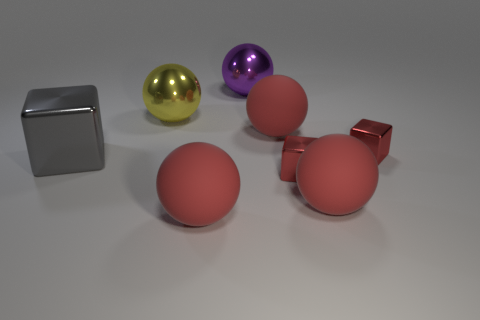Subtract all green cylinders. How many red balls are left? 3 Subtract all yellow spheres. How many spheres are left? 4 Subtract all yellow metallic balls. How many balls are left? 4 Subtract 1 blocks. How many blocks are left? 2 Subtract all spheres. How many objects are left? 3 Add 2 small red metal cubes. How many objects exist? 10 Subtract all gray balls. Subtract all yellow blocks. How many balls are left? 5 Subtract 0 brown cubes. How many objects are left? 8 Subtract all gray blocks. Subtract all metallic cubes. How many objects are left? 4 Add 1 purple shiny things. How many purple shiny things are left? 2 